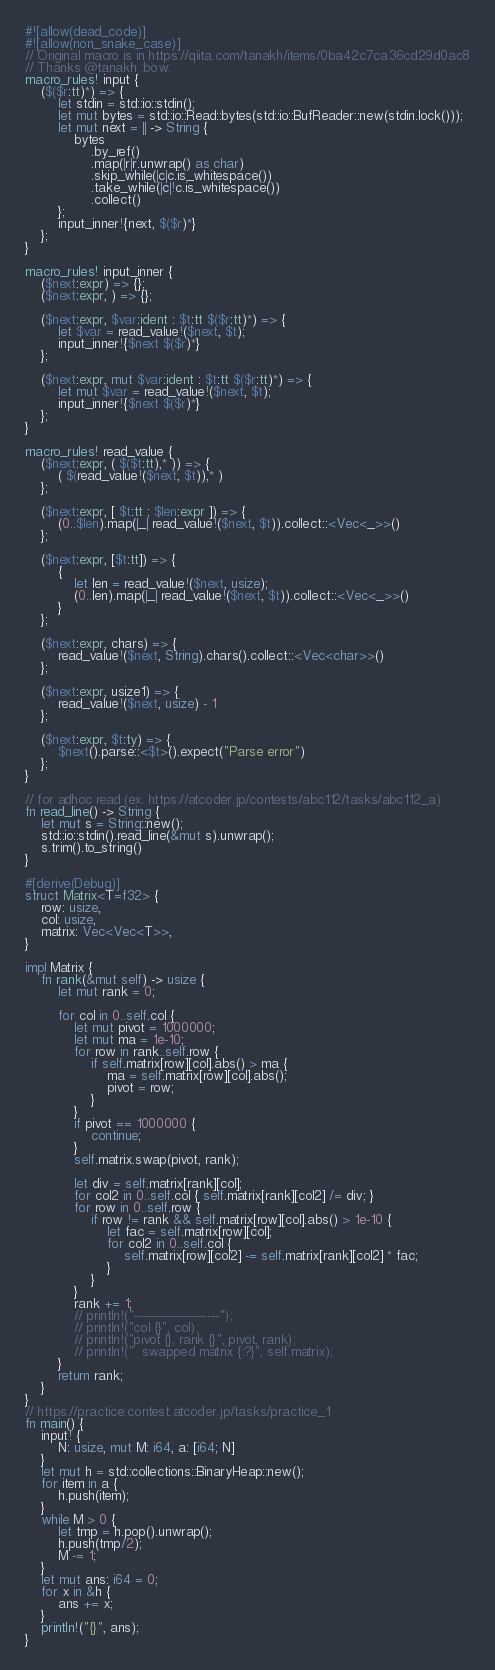<code> <loc_0><loc_0><loc_500><loc_500><_Rust_>#![allow(dead_code)]
#![allow(non_snake_case)]
// Original macro is in https://qiita.com/tanakh/items/0ba42c7ca36cd29d0ac8
// Thanks @tanakh :bow:
macro_rules! input {
    ($($r:tt)*) => {
        let stdin = std::io::stdin();
        let mut bytes = std::io::Read::bytes(std::io::BufReader::new(stdin.lock()));
        let mut next = || -> String {
            bytes
                .by_ref()
                .map(|r|r.unwrap() as char)
                .skip_while(|c|c.is_whitespace())
                .take_while(|c|!c.is_whitespace())
                .collect()
        };
        input_inner!{next, $($r)*}
    };
}
 
macro_rules! input_inner {
    ($next:expr) => {};
    ($next:expr, ) => {};
 
    ($next:expr, $var:ident : $t:tt $($r:tt)*) => {
        let $var = read_value!($next, $t);
        input_inner!{$next $($r)*}
    };
    
    ($next:expr, mut $var:ident : $t:tt $($r:tt)*) => {
        let mut $var = read_value!($next, $t);
        input_inner!{$next $($r)*}
    };
}
 
macro_rules! read_value {
    ($next:expr, ( $($t:tt),* )) => {
        ( $(read_value!($next, $t)),* )
    };
 
    ($next:expr, [ $t:tt ; $len:expr ]) => {
        (0..$len).map(|_| read_value!($next, $t)).collect::<Vec<_>>()
    };

    ($next:expr, [$t:tt]) => {
        {
            let len = read_value!($next, usize);
            (0..len).map(|_| read_value!($next, $t)).collect::<Vec<_>>()
        }
    };
 
    ($next:expr, chars) => {
        read_value!($next, String).chars().collect::<Vec<char>>()
    };
 
    ($next:expr, usize1) => {
        read_value!($next, usize) - 1
    };
 
    ($next:expr, $t:ty) => {
        $next().parse::<$t>().expect("Parse error")
    };
}

// for adhoc read (ex. https://atcoder.jp/contests/abc112/tasks/abc112_a)
fn read_line() -> String {
    let mut s = String::new();
    std::io::stdin().read_line(&mut s).unwrap();
    s.trim().to_string()
}

#[derive(Debug)]
struct Matrix<T=f32> {
    row: usize,
    col: usize,
    matrix: Vec<Vec<T>>,
}

impl Matrix {
    fn rank(&mut self) -> usize {
        let mut rank = 0;

        for col in 0..self.col {
            let mut pivot = 1000000;
            let mut ma = 1e-10;
            for row in rank..self.row {
                if self.matrix[row][col].abs() > ma {
                    ma = self.matrix[row][col].abs();
                    pivot = row;
                }
            }
            if pivot == 1000000 {
                continue;
            }
            self.matrix.swap(pivot, rank);

            let div = self.matrix[rank][col];
            for col2 in 0..self.col { self.matrix[rank][col2] /= div; }
            for row in 0..self.row {
                if row != rank && self.matrix[row][col].abs() > 1e-10 {
                    let fac = self.matrix[row][col];
                    for col2 in 0..self.col {
                        self.matrix[row][col2] -= self.matrix[rank][col2] * fac;
                    }
                }
            }
            rank += 1;
            // println!("---------------------");
            // println!("col {}", col);
            // println!("pivot {}, rank {}", pivot, rank);
            // println!("  swapped matrix {:?}", self.matrix);
        }
        return rank;
    }
}
// https://practice.contest.atcoder.jp/tasks/practice_1
fn main() {
    input! {
        N: usize, mut M: i64, a: [i64; N]
    }
    let mut h = std::collections::BinaryHeap::new();
    for item in a {
        h.push(item);
    }
    while M > 0 {
        let tmp = h.pop().unwrap();
        h.push(tmp/2);
        M -= 1;
    }
    let mut ans: i64 = 0;
    for x in &h {
        ans += x;
    }
    println!("{}", ans);
}
</code> 